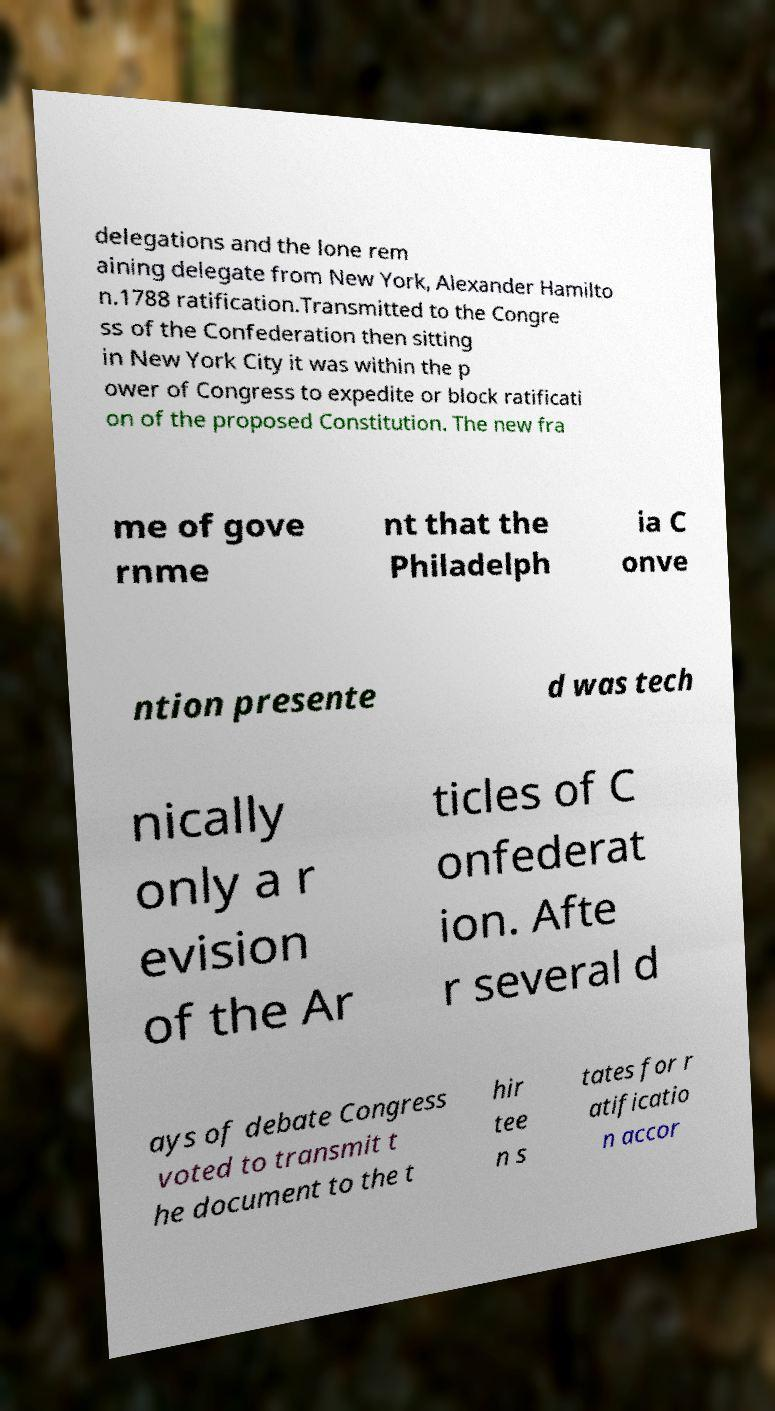For documentation purposes, I need the text within this image transcribed. Could you provide that? delegations and the lone rem aining delegate from New York, Alexander Hamilto n.1788 ratification.Transmitted to the Congre ss of the Confederation then sitting in New York City it was within the p ower of Congress to expedite or block ratificati on of the proposed Constitution. The new fra me of gove rnme nt that the Philadelph ia C onve ntion presente d was tech nically only a r evision of the Ar ticles of C onfederat ion. Afte r several d ays of debate Congress voted to transmit t he document to the t hir tee n s tates for r atificatio n accor 